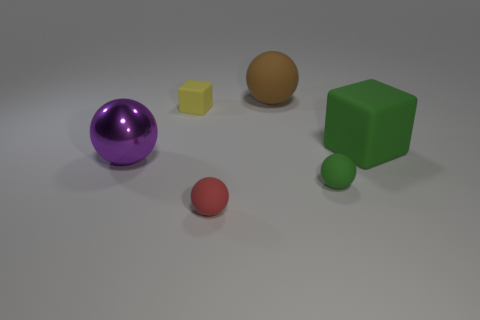There is a green thing that is the same size as the red rubber thing; what is it made of?
Give a very brief answer. Rubber. Does the red thing have the same material as the purple object?
Provide a short and direct response. No. What number of objects are either green rubber spheres or purple rubber cubes?
Your response must be concise. 1. There is a tiny rubber object on the right side of the small red matte object; what shape is it?
Provide a succinct answer. Sphere. The large thing that is the same material as the large green cube is what color?
Offer a terse response. Brown. What is the material of the other big object that is the same shape as the big metallic thing?
Your response must be concise. Rubber. What shape is the yellow thing?
Your response must be concise. Cube. What is the tiny object that is both on the right side of the yellow rubber cube and on the left side of the brown ball made of?
Make the answer very short. Rubber. What is the shape of the tiny yellow object that is made of the same material as the red thing?
Provide a short and direct response. Cube. There is a brown object that is made of the same material as the tiny green thing; what size is it?
Provide a short and direct response. Large. 